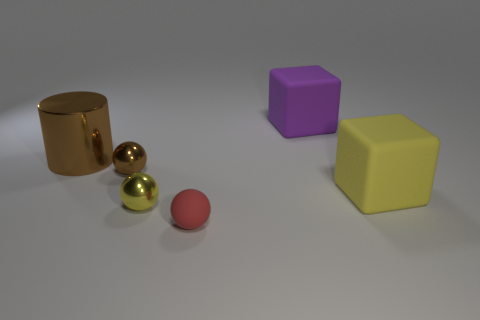Subtract 1 balls. How many balls are left? 2 Add 3 tiny blue matte spheres. How many objects exist? 9 Subtract all cubes. How many objects are left? 4 Add 5 brown objects. How many brown objects are left? 7 Add 4 large brown cylinders. How many large brown cylinders exist? 5 Subtract 0 blue balls. How many objects are left? 6 Subtract all tiny metal objects. Subtract all small red rubber objects. How many objects are left? 3 